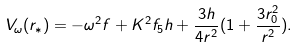<formula> <loc_0><loc_0><loc_500><loc_500>V _ { \omega } ( r _ { * } ) = - \omega ^ { 2 } f + K ^ { 2 } f _ { 5 } h + \frac { 3 h } { 4 r ^ { 2 } } ( 1 + \frac { 3 r _ { 0 } ^ { 2 } } { r ^ { 2 } } ) .</formula> 